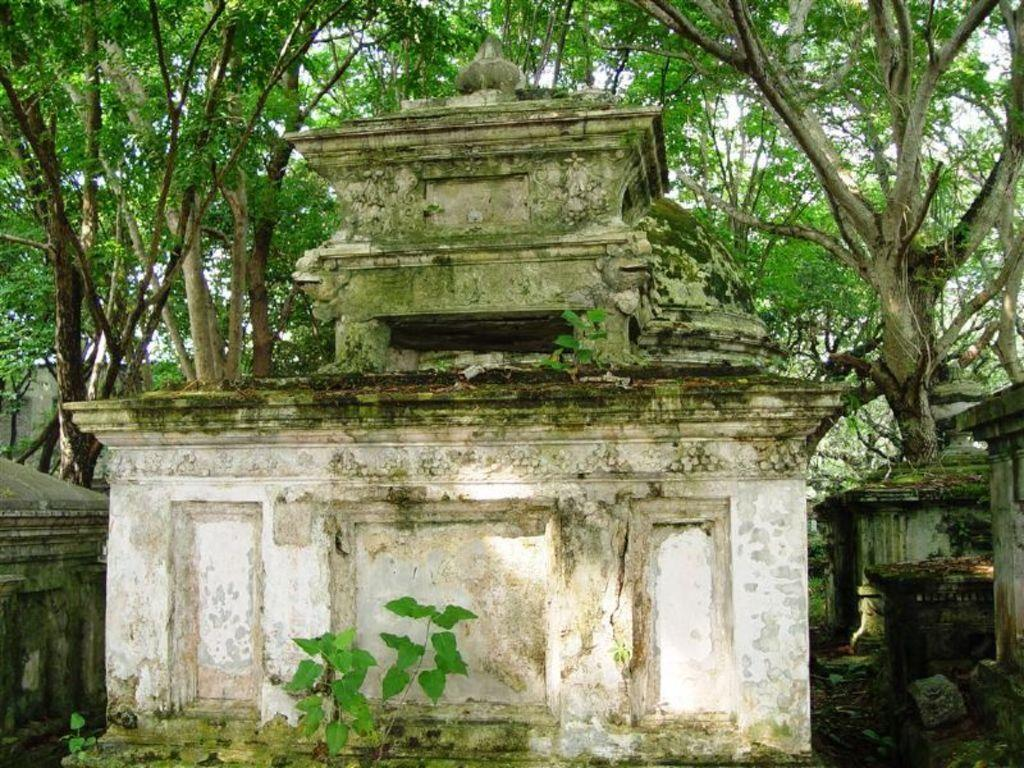What structures are present in the image? There are buildings in the image. What type of natural elements can be seen in the background of the image? There are trees in the background of the image. What part of the natural environment is visible in the image? The sky is visible in the background of the image. What airplane route can be seen in the image? There is no airplane or route visible in the image. What scientific discoveries are depicted in the image? The image does not depict any scientific discoveries discoveries; it features buildings, trees, and the sky. 